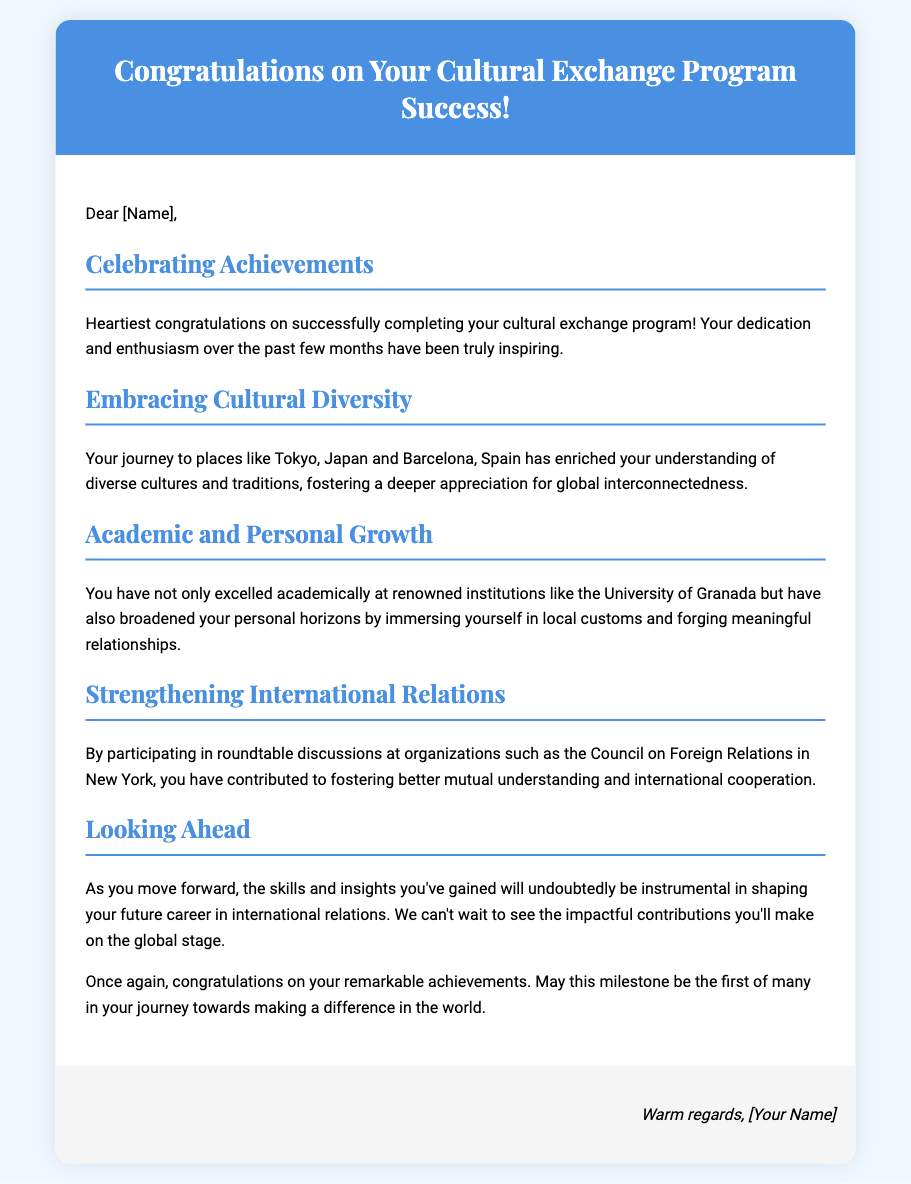What is the title of the card? The title of the card is stated in the header section of the document.
Answer: Congratulations on Your Cultural Exchange Program Success! Who is the greeting card addressed to? The greeting card uses a placeholder for the recipient's name, indicating it is personalized.
Answer: [Name] Which countries are mentioned in the card? The document notes specific locations associated with the cultural exchange experiences.
Answer: Tokyo, Japan and Barcelona, Spain What type of institutions did the recipient excel at? This information can be found under the "Academic and Personal Growth" section of the card.
Answer: Renowned institutions What skills are mentioned as being gained from the program? The card emphasizes the insights that will help in future endeavors.
Answer: Skills and insights What organization is mentioned in relation to international relations? The card provides a specific name of an organization where discussions took place.
Answer: Council on Foreign Relations What is the overall tone of the message? The message conveys a celebratory and encouraging tone throughout the content.
Answer: Celebratory What is signed at the end of the card? The footer includes a space for the sender's name, indicating a personal touch.
Answer: [Your Name] 